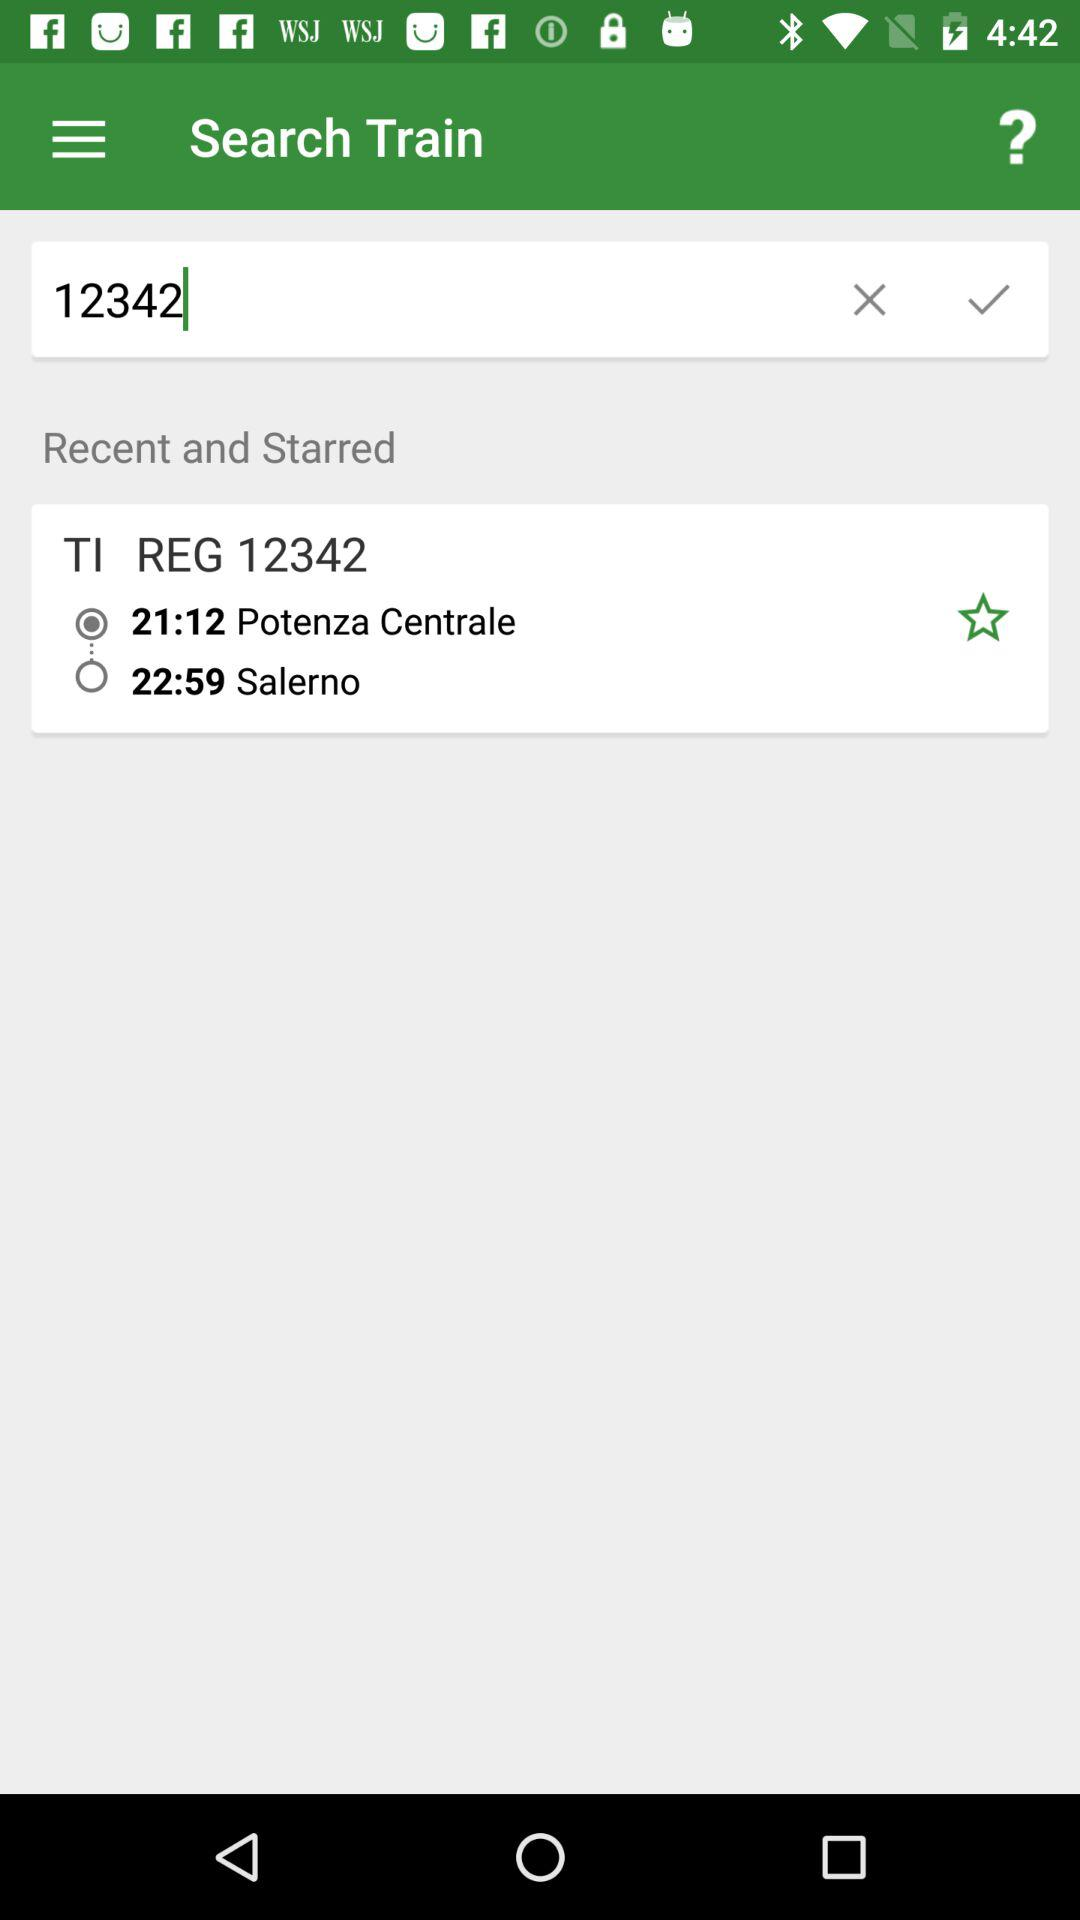What is the the registration number?
When the provided information is insufficient, respond with <no answer>. <no answer> 